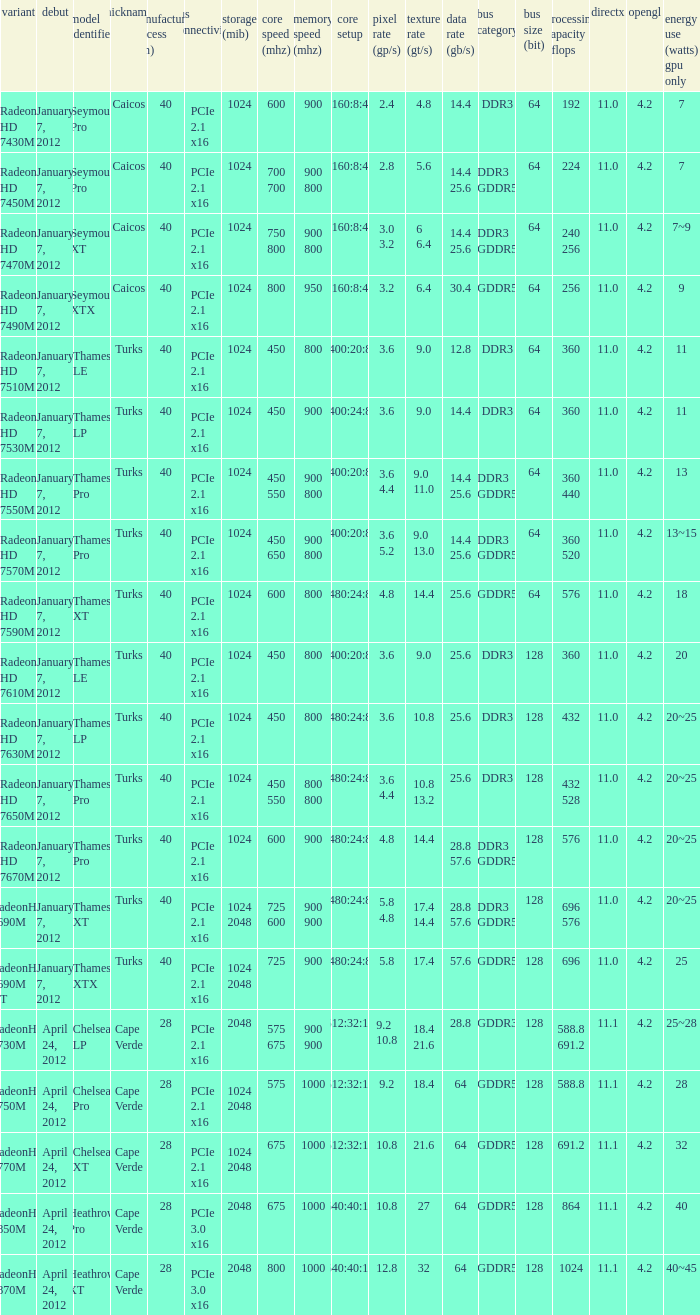How many texture (gt/s) the card has if the tdp (watts) GPU only is 18? 1.0. 